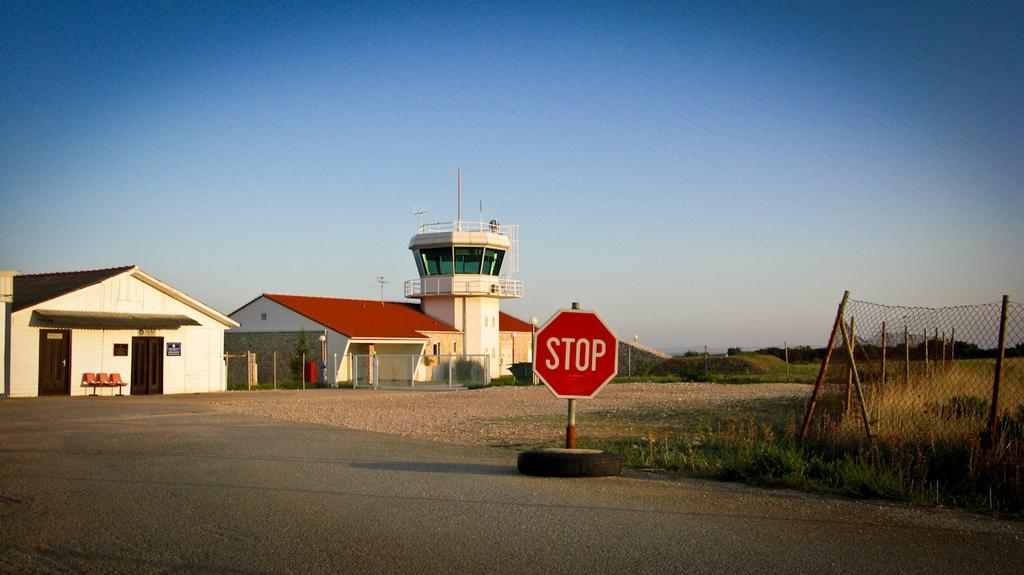Could you give a brief overview of what you see in this image? In this picture we can see a sign board and a Tyre on the ground, here we can see buildings, chairs, trees and some objects and we can see sky in the background. 